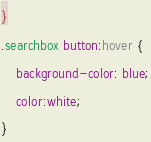Convert code to text. <code><loc_0><loc_0><loc_500><loc_500><_CSS_>}
.searchbox button:hover {
    background-color: blue;
    color:white;
}</code> 